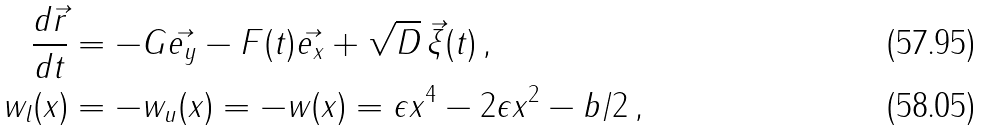<formula> <loc_0><loc_0><loc_500><loc_500>\frac { d \vec { r } } { d t } & = - G \vec { e _ { y } } - F ( t ) \vec { e _ { x } } + \sqrt { D } \, \vec { \xi } ( t ) \, , \\ w _ { l } ( x ) & = - w _ { u } ( x ) = - w ( x ) = \epsilon x ^ { 4 } - 2 \epsilon x ^ { 2 } - b / 2 \, ,</formula> 